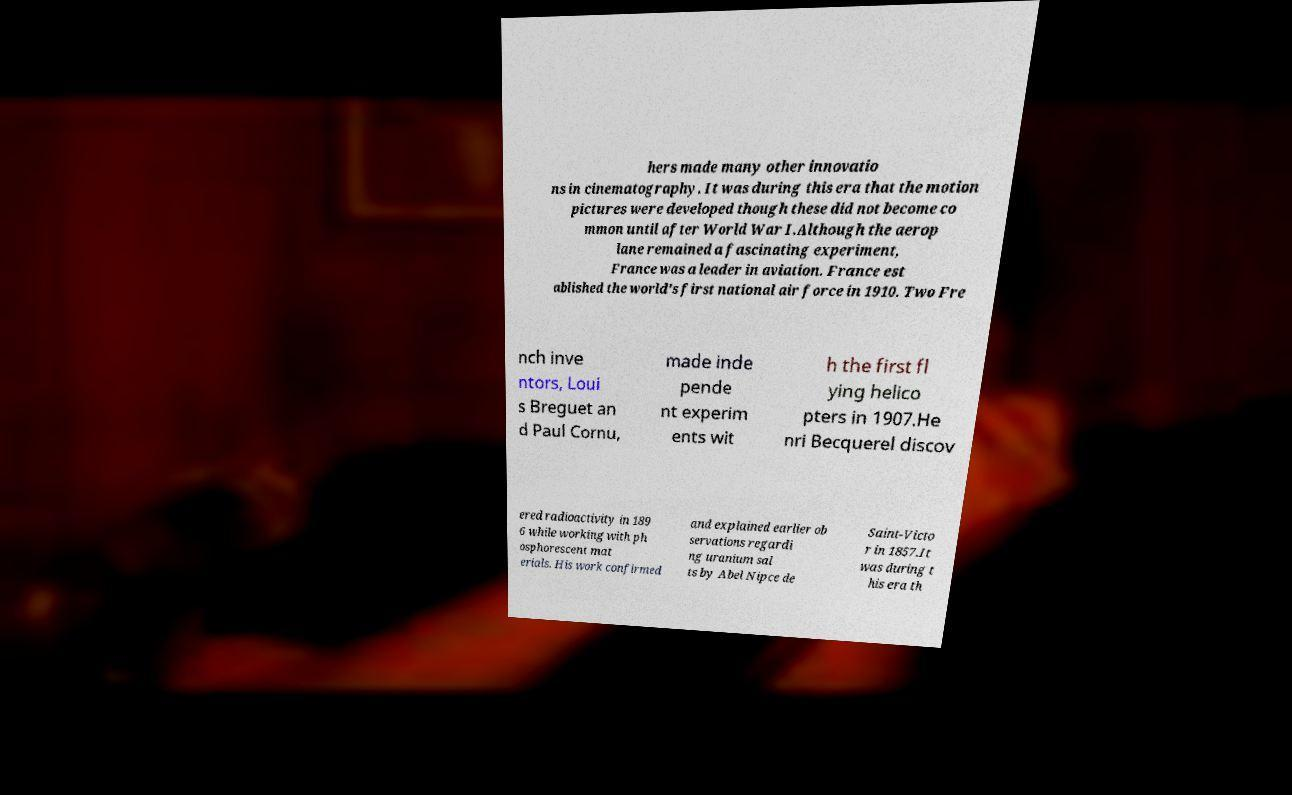Could you extract and type out the text from this image? hers made many other innovatio ns in cinematography. It was during this era that the motion pictures were developed though these did not become co mmon until after World War I.Although the aerop lane remained a fascinating experiment, France was a leader in aviation. France est ablished the world's first national air force in 1910. Two Fre nch inve ntors, Loui s Breguet an d Paul Cornu, made inde pende nt experim ents wit h the first fl ying helico pters in 1907.He nri Becquerel discov ered radioactivity in 189 6 while working with ph osphorescent mat erials. His work confirmed and explained earlier ob servations regardi ng uranium sal ts by Abel Nipce de Saint-Victo r in 1857.It was during t his era th 